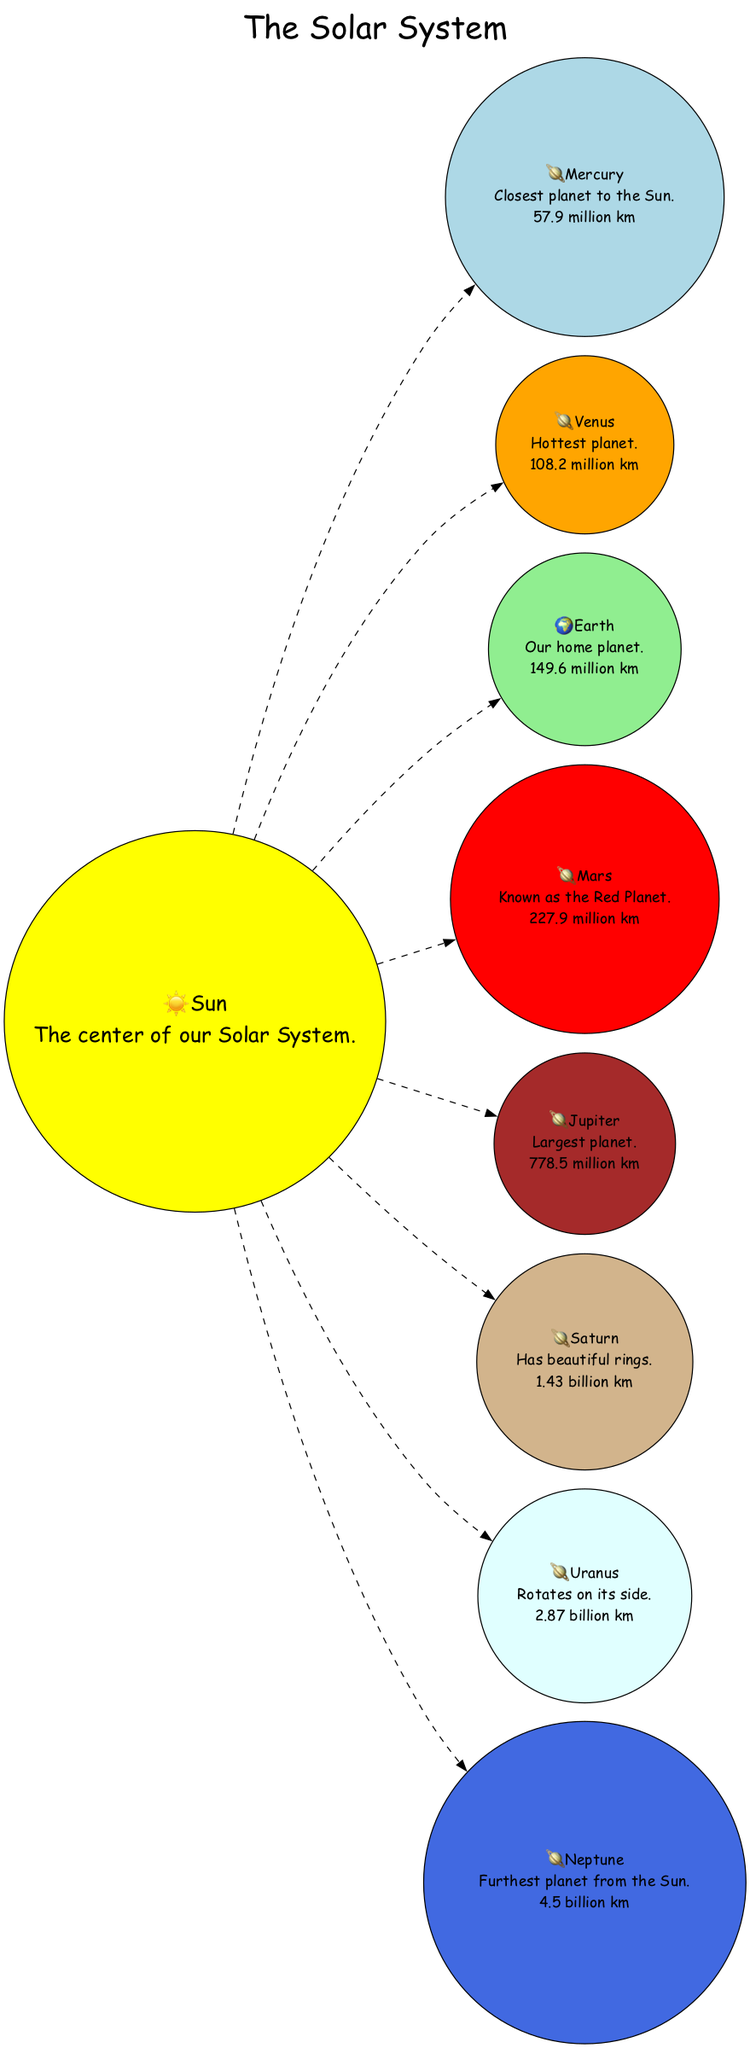What is the closest planet to the Sun? The diagram indicates that Mercury is the closest planet to the Sun as stated in the fact associated with Mercury.
Answer: Mercury Which planet is known as the Red Planet? The diagram highlights Mars and specifies its fact as "Known as the Red Planet," clearly identifying it.
Answer: Mars How far is Earth from the Sun? The diagram provides the fact related to Earth's distance, which is "149.6 million km," directly indicating how far it is from the Sun.
Answer: 149.6 million km Which planet has the largest distance from the Sun? Looking at the distances in the diagram, Neptune is noted for being the "Furthest planet from the Sun," confirming it has the largest distance.
Answer: Neptune How many planets are shown in the diagram? Counting all the planets listed in the diagram, there are 8 planets in total surrounding the Sun.
Answer: 8 Which planet is the hottest? The diagram explicitly labels Venus as "Hottest planet," making it the answer to the question.
Answer: Venus What planet has beautiful rings? Saturn is identified in the diagram with the fact "Has beautiful rings," which directly answers this question.
Answer: Saturn What color is the node for Jupiter? The diagram provides a color scheme for the nodes, and Jupiter is represented with a brown color.
Answer: brown Which planet rotates on its side? The diagram states that Uranus "Rotates on its side," making Uranus the answer here based on its specific fact.
Answer: Uranus 